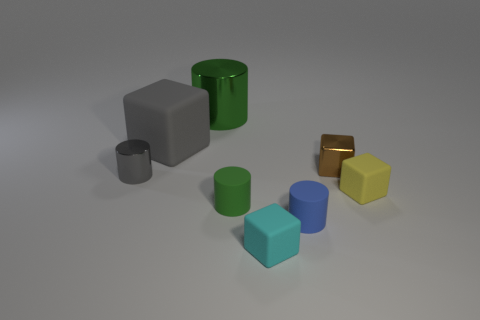Subtract all small cyan matte blocks. How many blocks are left? 3 Subtract 2 cylinders. How many cylinders are left? 2 Add 1 large blue matte cylinders. How many objects exist? 9 Subtract all large metallic cylinders. Subtract all big gray cubes. How many objects are left? 6 Add 1 rubber cylinders. How many rubber cylinders are left? 3 Add 5 gray cylinders. How many gray cylinders exist? 6 Subtract all cyan cubes. How many cubes are left? 3 Subtract 2 green cylinders. How many objects are left? 6 Subtract all cyan cylinders. Subtract all gray cubes. How many cylinders are left? 4 Subtract all gray spheres. How many gray cubes are left? 1 